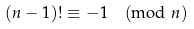<formula> <loc_0><loc_0><loc_500><loc_500>( n - 1 ) ! \equiv - 1 { \pmod { n } }</formula> 